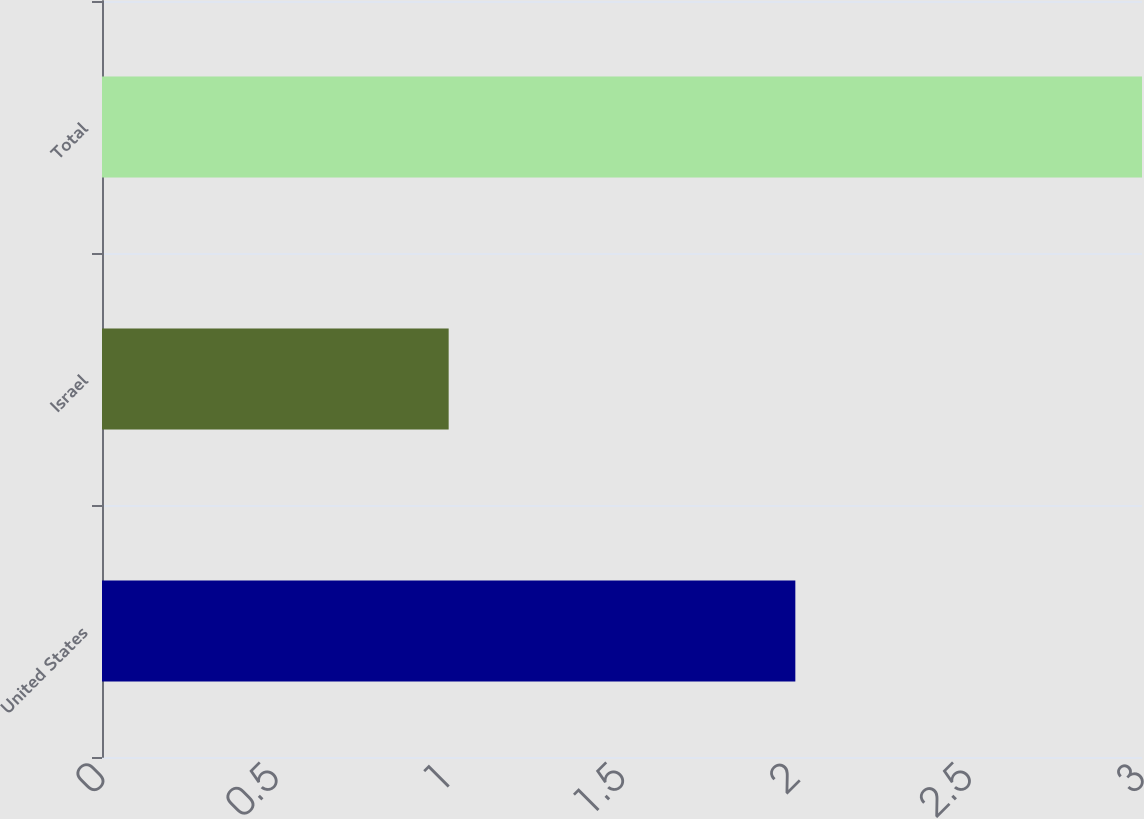Convert chart to OTSL. <chart><loc_0><loc_0><loc_500><loc_500><bar_chart><fcel>United States<fcel>Israel<fcel>Total<nl><fcel>2<fcel>1<fcel>3<nl></chart> 